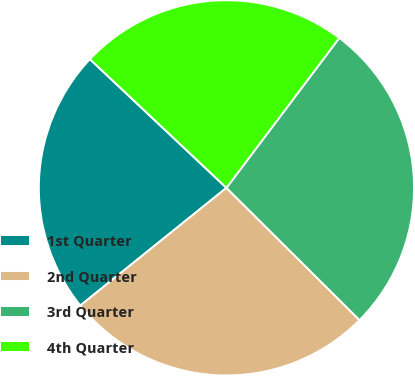Convert chart to OTSL. <chart><loc_0><loc_0><loc_500><loc_500><pie_chart><fcel>1st Quarter<fcel>2nd Quarter<fcel>3rd Quarter<fcel>4th Quarter<nl><fcel>22.82%<fcel>26.76%<fcel>27.18%<fcel>23.24%<nl></chart> 